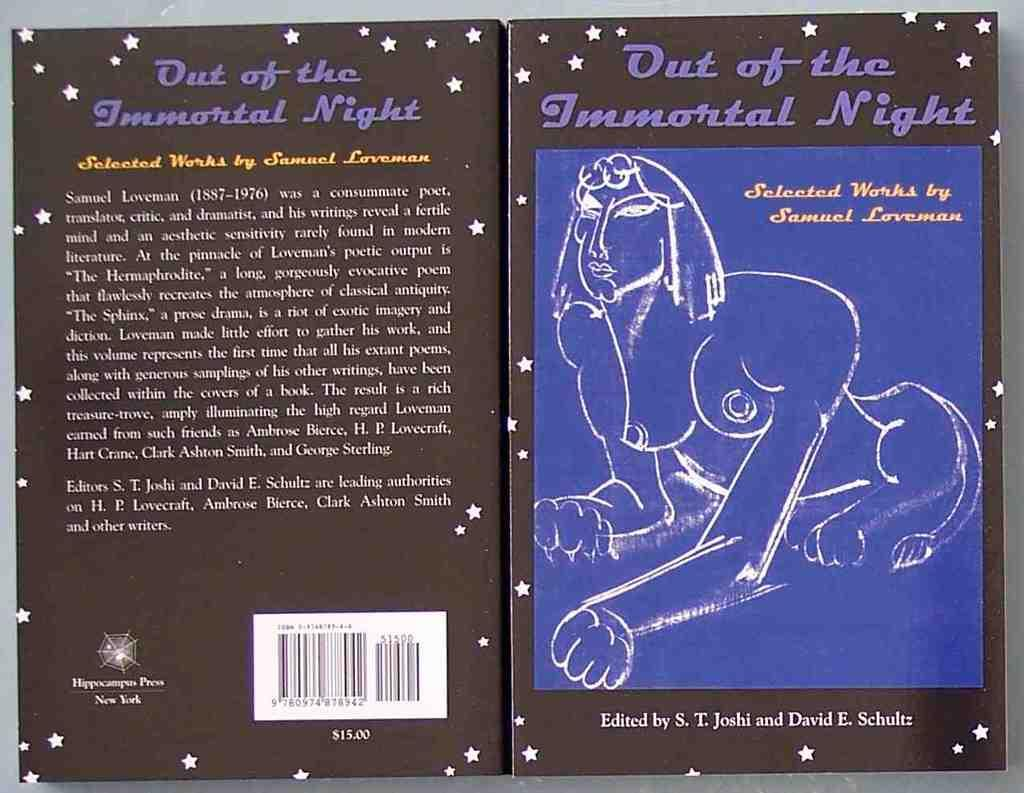What object is present in the image that has text and an image on it? There is a box in the image that has text and an image on it. What additional feature can be found on the box? The box also has a barcode on it. What type of nut is being protested against in the image? There is no protest or nut present in the image; it only features a box with text, an image, and a barcode. 